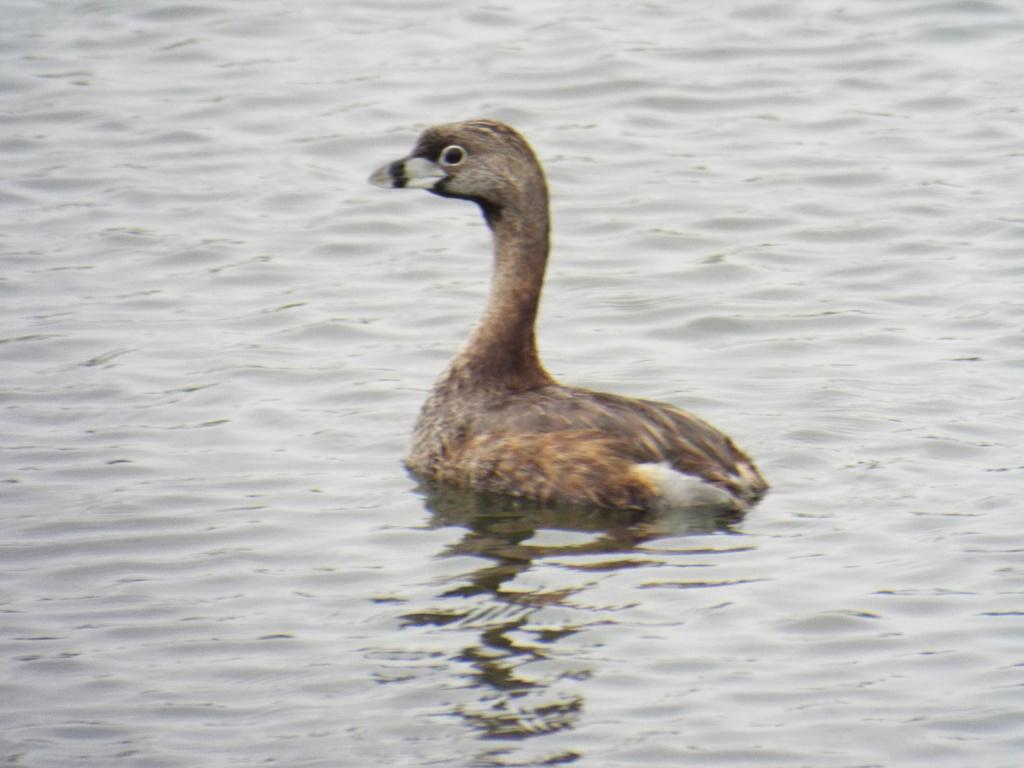What type of animal can be seen in the water in the image? There is a bird in the water in the image. Can you describe the bird's location in the image? The bird is in the water. What type of plastic fold can be seen in the image? There is no plastic fold present in the image; it only features a bird in the water. 